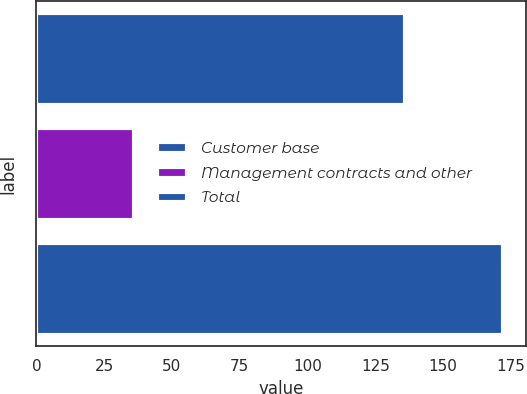Convert chart. <chart><loc_0><loc_0><loc_500><loc_500><bar_chart><fcel>Customer base<fcel>Management contracts and other<fcel>Total<nl><fcel>135.9<fcel>36<fcel>171.9<nl></chart> 